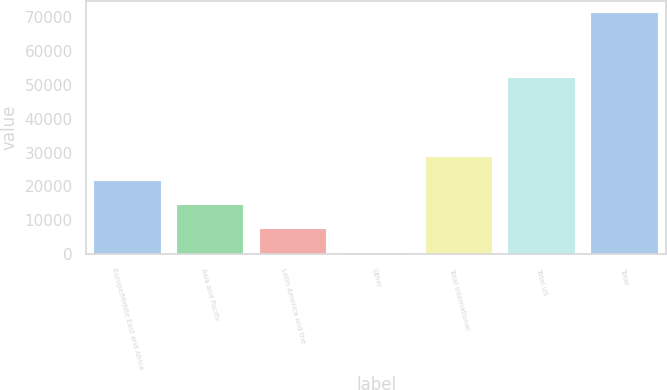<chart> <loc_0><loc_0><loc_500><loc_500><bar_chart><fcel>Europe/Middle East and Africa<fcel>Asia and Pacific<fcel>Latin America and the<fcel>Other<fcel>Total international<fcel>Total US<fcel>Total<nl><fcel>21696.5<fcel>14600<fcel>7503.5<fcel>407<fcel>28793<fcel>52137<fcel>71372<nl></chart> 